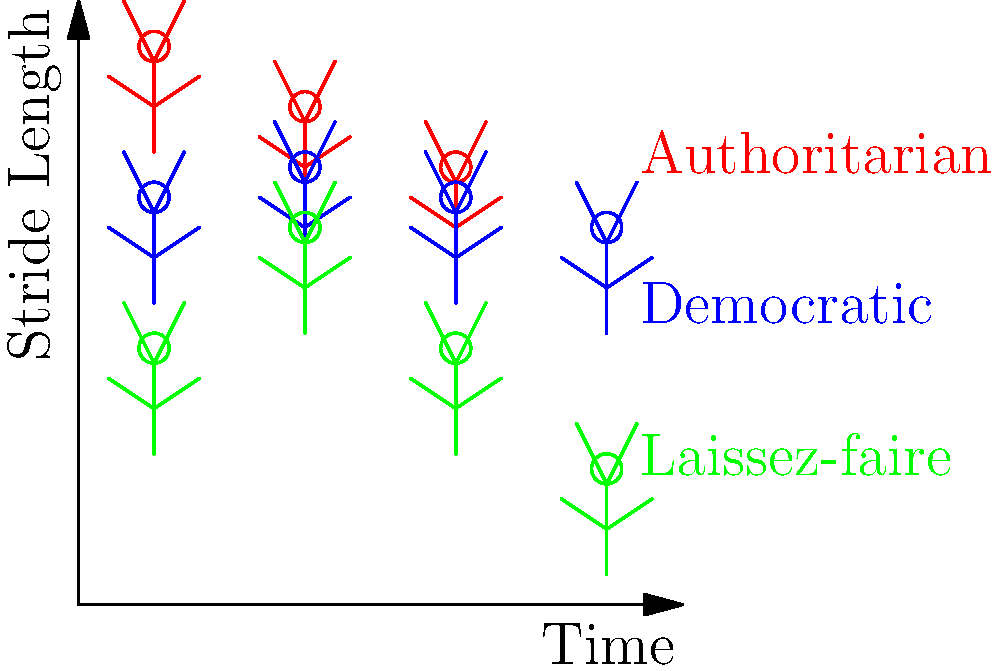In your latest political allegory novel, you've depicted three leadership styles through their gait cycles. Analyzing the stick figure animations above, which leadership style demonstrates the most consistent stride length over time, potentially symbolizing stability in governance? To answer this question, we need to analyze the gait cycles of each leadership style represented in the stick figure animation:

1. Authoritarian (Red):
   - The stride length decreases consistently over time.
   - This could symbolize a gradual loss of power or efficiency in an authoritarian system.

2. Democratic (Blue):
   - The stride length oscillates slightly but remains relatively consistent.
   - This could represent the balanced nature of democratic systems, with minor fluctuations due to changing public opinion or election cycles.

3. Laissez-faire (Green):
   - The stride length shows large oscillations over time.
   - This could symbolize the unpredictable nature of a hands-off leadership approach, with significant variations in outcomes.

Comparing these three styles:
- The authoritarian style shows a consistent change, but it's a decline rather than stability.
- The laissez-faire style shows the most variation, indicating the least stability.
- The democratic style maintains the most consistent stride length, with only minor fluctuations.

Therefore, the democratic leadership style demonstrates the most consistent stride length over time, potentially symbolizing stability in governance.
Answer: Democratic leadership style 